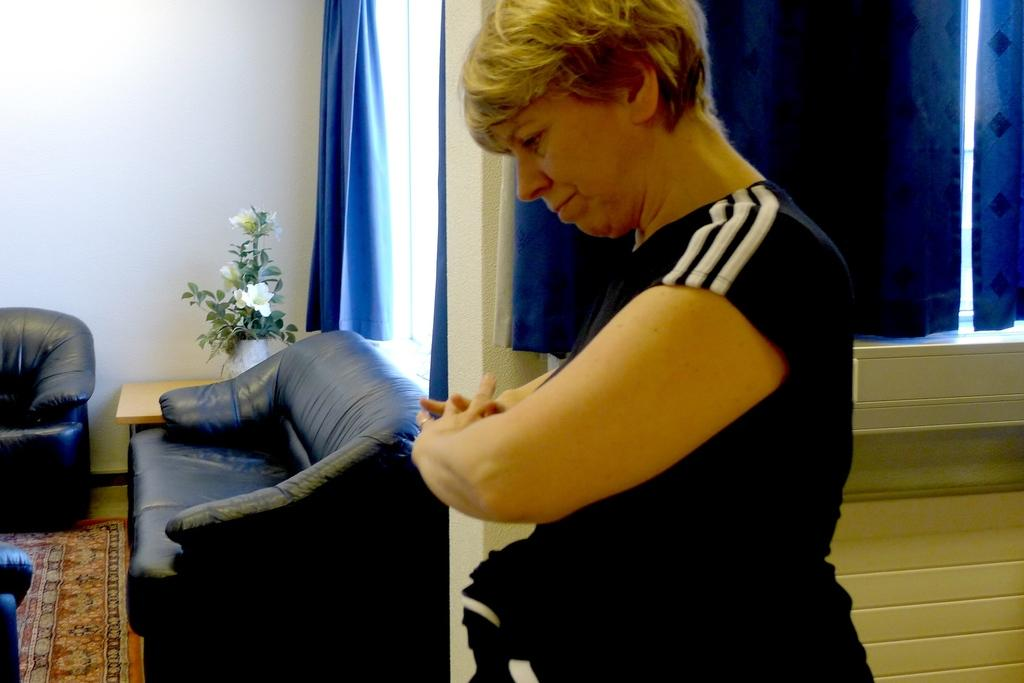Who is the main subject in the foreground of the image? There is an old woman in the foreground of the image. What is the old woman doing in the image? The old woman is doing some kind of exercise in the image. Can you describe any furniture visible in the image? Yes, there is a couch on the left side of the image. How many grapes are on the couch in the image? There are no grapes present in the image; the couch is empty. 